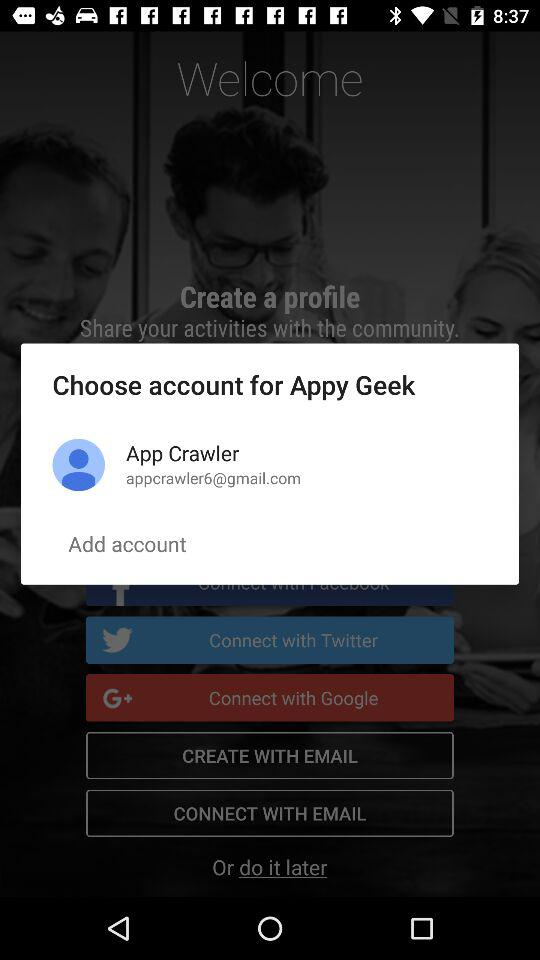What is the user name for the "Appy Geek" account? The user name for the "Appy Geek" account is App Crawler. 